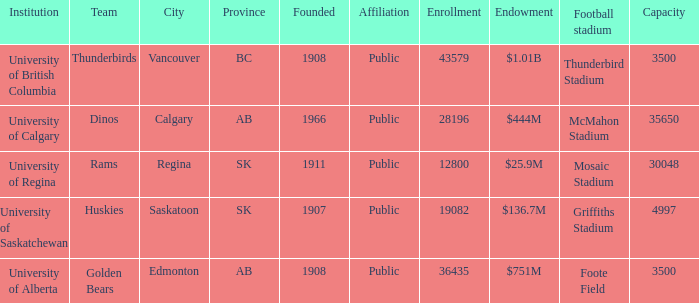What year was mcmahon stadium founded? 1966.0. 